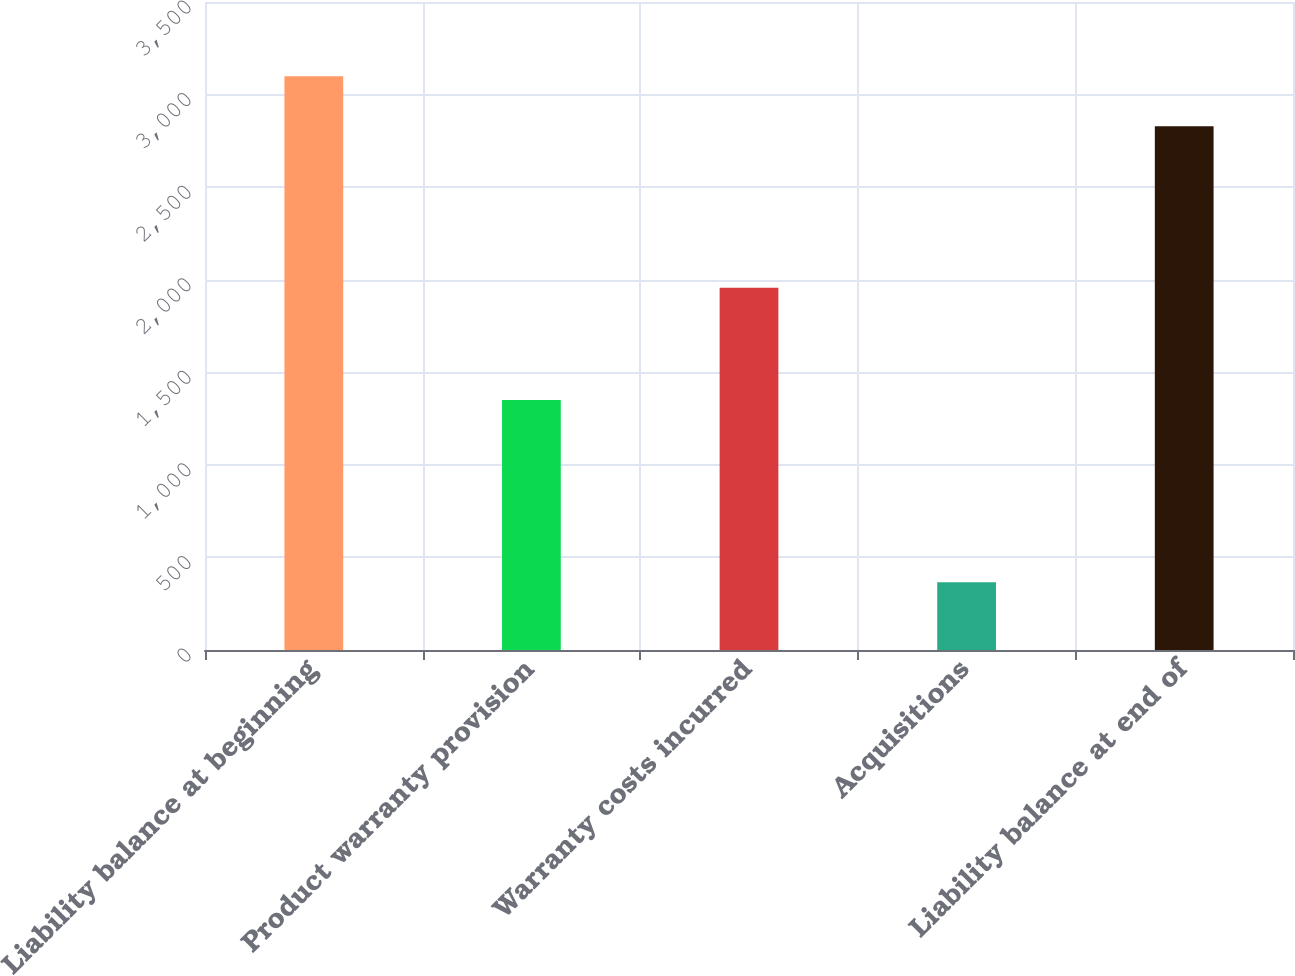Convert chart. <chart><loc_0><loc_0><loc_500><loc_500><bar_chart><fcel>Liability balance at beginning<fcel>Product warranty provision<fcel>Warranty costs incurred<fcel>Acquisitions<fcel>Liability balance at end of<nl><fcel>3099.4<fcel>1350<fcel>1957<fcel>366<fcel>2829<nl></chart> 